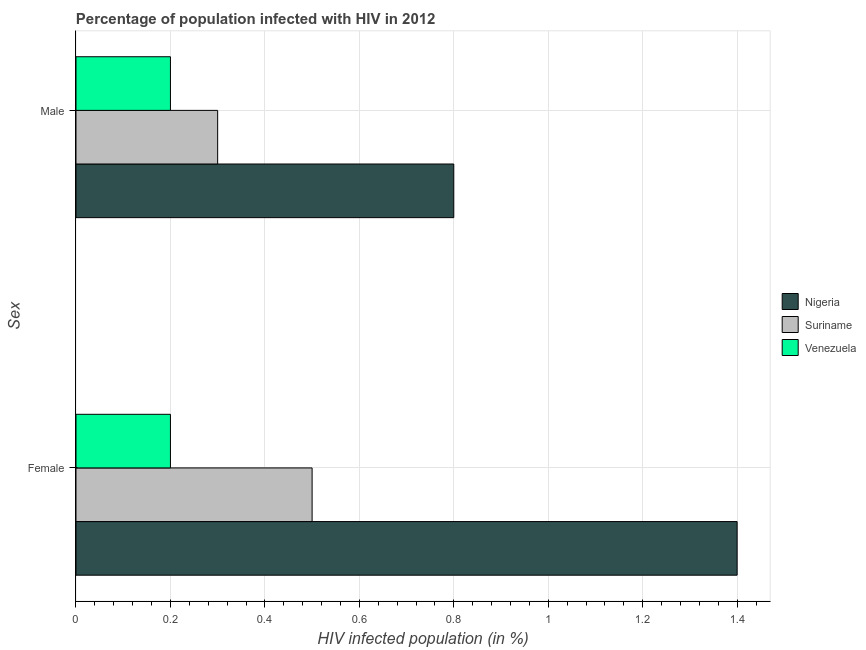How many different coloured bars are there?
Your answer should be very brief. 3. How many groups of bars are there?
Your answer should be compact. 2. Are the number of bars per tick equal to the number of legend labels?
Offer a terse response. Yes. What is the percentage of females who are infected with hiv in Suriname?
Your response must be concise. 0.5. Across all countries, what is the minimum percentage of females who are infected with hiv?
Keep it short and to the point. 0.2. In which country was the percentage of males who are infected with hiv maximum?
Offer a terse response. Nigeria. In which country was the percentage of males who are infected with hiv minimum?
Provide a succinct answer. Venezuela. What is the difference between the percentage of females who are infected with hiv in Suriname and that in Nigeria?
Offer a terse response. -0.9. What is the difference between the percentage of males who are infected with hiv in Suriname and the percentage of females who are infected with hiv in Nigeria?
Keep it short and to the point. -1.1. What is the average percentage of females who are infected with hiv per country?
Your response must be concise. 0.7. What is the difference between the percentage of females who are infected with hiv and percentage of males who are infected with hiv in Venezuela?
Offer a very short reply. 0. What is the ratio of the percentage of males who are infected with hiv in Nigeria to that in Suriname?
Make the answer very short. 2.67. Is the percentage of males who are infected with hiv in Venezuela less than that in Suriname?
Provide a short and direct response. Yes. What does the 3rd bar from the top in Male represents?
Give a very brief answer. Nigeria. What does the 3rd bar from the bottom in Female represents?
Give a very brief answer. Venezuela. Are all the bars in the graph horizontal?
Offer a terse response. Yes. Are the values on the major ticks of X-axis written in scientific E-notation?
Your response must be concise. No. How many legend labels are there?
Your answer should be very brief. 3. How are the legend labels stacked?
Provide a short and direct response. Vertical. What is the title of the graph?
Your answer should be compact. Percentage of population infected with HIV in 2012. What is the label or title of the X-axis?
Your answer should be very brief. HIV infected population (in %). What is the label or title of the Y-axis?
Make the answer very short. Sex. What is the HIV infected population (in %) in Nigeria in Female?
Offer a very short reply. 1.4. What is the HIV infected population (in %) of Suriname in Female?
Keep it short and to the point. 0.5. What is the HIV infected population (in %) in Nigeria in Male?
Ensure brevity in your answer.  0.8. What is the HIV infected population (in %) in Suriname in Male?
Make the answer very short. 0.3. Across all Sex, what is the maximum HIV infected population (in %) in Suriname?
Make the answer very short. 0.5. Across all Sex, what is the minimum HIV infected population (in %) in Venezuela?
Ensure brevity in your answer.  0.2. What is the total HIV infected population (in %) in Venezuela in the graph?
Provide a succinct answer. 0.4. What is the difference between the HIV infected population (in %) of Suriname in Female and that in Male?
Provide a succinct answer. 0.2. What is the difference between the HIV infected population (in %) of Nigeria in Female and the HIV infected population (in %) of Suriname in Male?
Give a very brief answer. 1.1. What is the difference between the HIV infected population (in %) of Suriname in Female and the HIV infected population (in %) of Venezuela in Male?
Ensure brevity in your answer.  0.3. What is the average HIV infected population (in %) of Nigeria per Sex?
Offer a terse response. 1.1. What is the difference between the HIV infected population (in %) in Nigeria and HIV infected population (in %) in Suriname in Female?
Provide a succinct answer. 0.9. What is the difference between the HIV infected population (in %) of Nigeria and HIV infected population (in %) of Suriname in Male?
Your response must be concise. 0.5. What is the difference between the HIV infected population (in %) of Nigeria and HIV infected population (in %) of Venezuela in Male?
Make the answer very short. 0.6. What is the difference between the HIV infected population (in %) in Suriname and HIV infected population (in %) in Venezuela in Male?
Give a very brief answer. 0.1. What is the ratio of the HIV infected population (in %) in Nigeria in Female to that in Male?
Give a very brief answer. 1.75. What is the ratio of the HIV infected population (in %) of Suriname in Female to that in Male?
Provide a succinct answer. 1.67. What is the difference between the highest and the second highest HIV infected population (in %) of Venezuela?
Offer a very short reply. 0. 